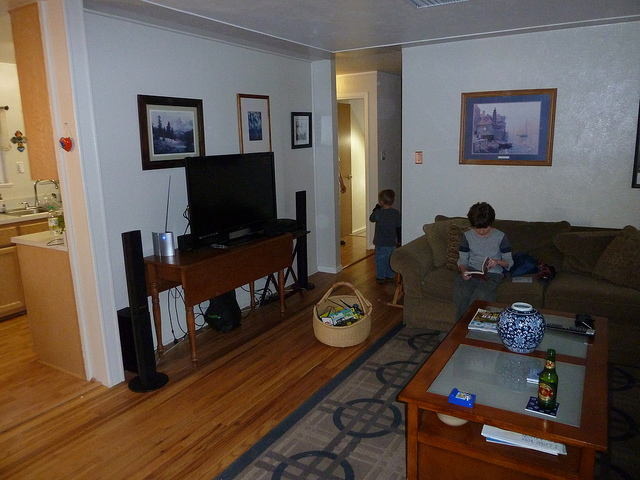<image>What is in the blue vase? I don't know what is in the blue vase. It can be nothing or flowers. What Holiday does this picture depict? It is ambiguous which holiday the picture is depicting. It could be Christmas, Easter, or even a Birthday. What is in the blue vase? It is unknown what is in the blue vase. There is nothing visible in the image. What Holiday does this picture depict? I don't know what holiday this picture depicts. It can be either Christmas, Easter, or none. 